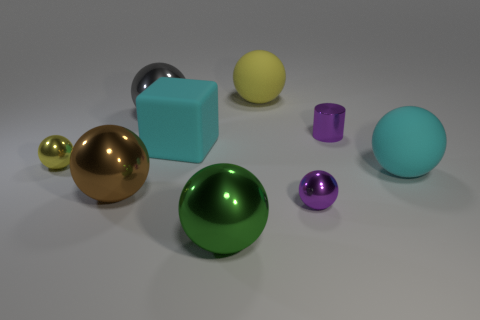What number of matte things are either brown spheres or big gray objects?
Your answer should be very brief. 0. There is a cyan sphere behind the shiny sphere that is in front of the small purple shiny ball; how big is it?
Give a very brief answer. Large. There is a tiny metal sphere that is right of the large green sphere; is it the same color as the tiny metal thing that is behind the big matte block?
Ensure brevity in your answer.  Yes. The tiny thing that is behind the big brown object and right of the large green shiny thing is what color?
Ensure brevity in your answer.  Purple. Does the gray sphere have the same material as the big cyan sphere?
Make the answer very short. No. How many small objects are either purple objects or cyan cubes?
Offer a terse response. 2. There is a small sphere that is made of the same material as the small yellow thing; what color is it?
Your answer should be very brief. Purple. There is a tiny metal ball left of the large gray object; what color is it?
Your answer should be very brief. Yellow. What number of small objects have the same color as the shiny cylinder?
Ensure brevity in your answer.  1. Is the number of large rubber spheres that are on the right side of the large cyan rubber ball less than the number of purple shiny things in front of the large brown shiny ball?
Your answer should be compact. Yes. 